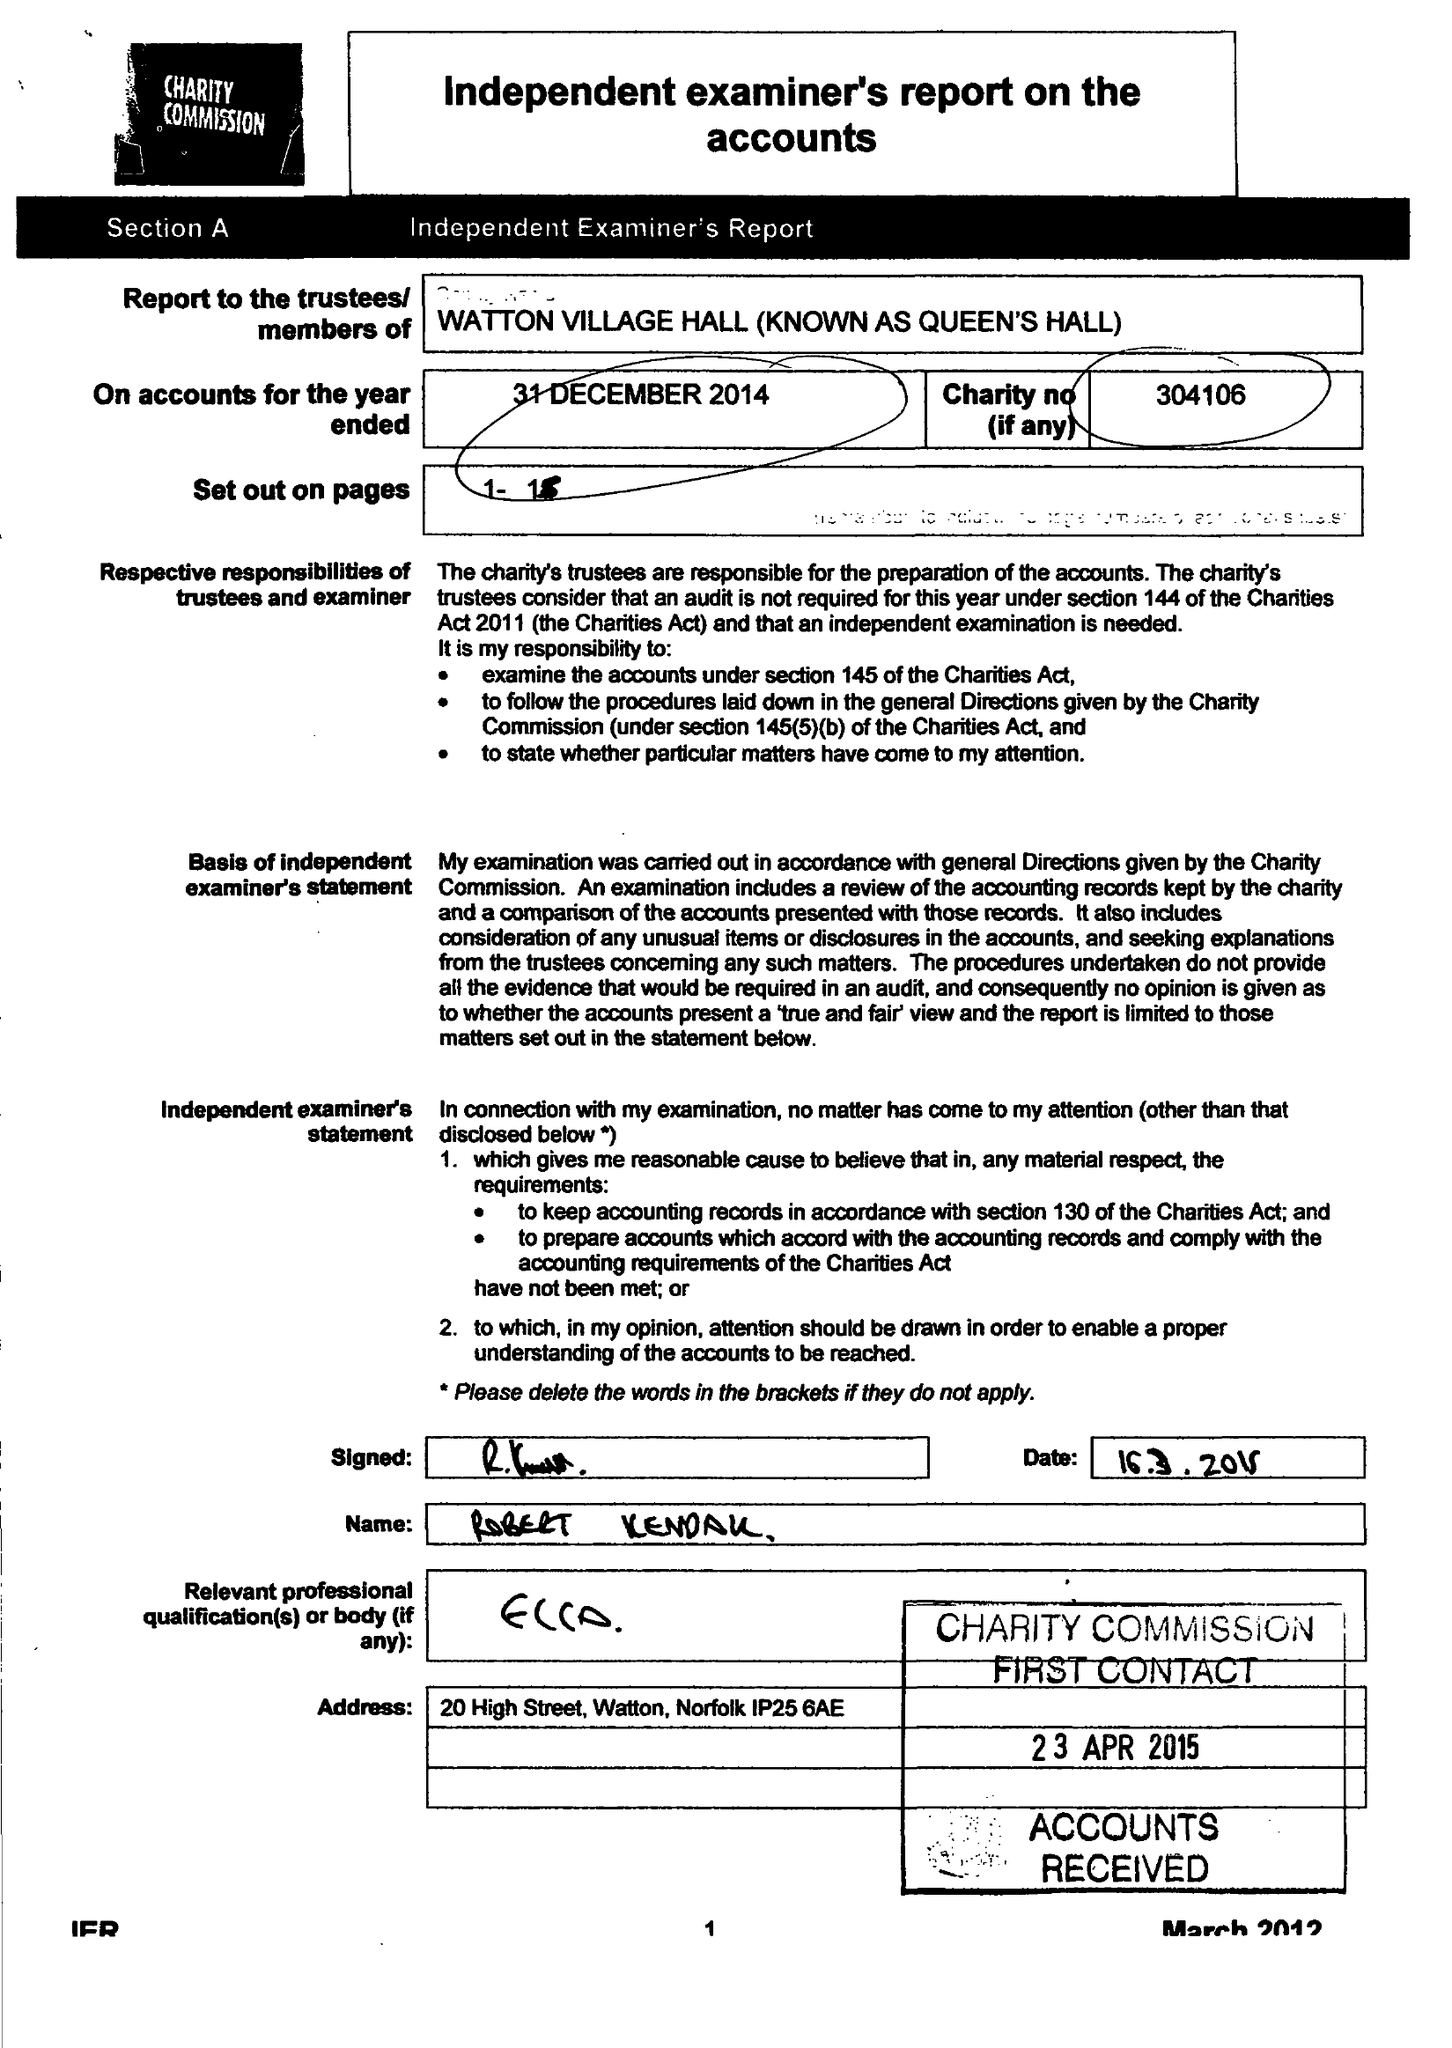What is the value for the income_annually_in_british_pounds?
Answer the question using a single word or phrase. 32790.00 